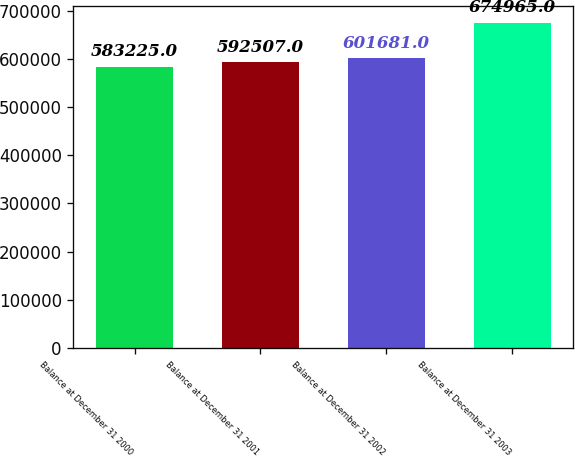Convert chart to OTSL. <chart><loc_0><loc_0><loc_500><loc_500><bar_chart><fcel>Balance at December 31 2000<fcel>Balance at December 31 2001<fcel>Balance at December 31 2002<fcel>Balance at December 31 2003<nl><fcel>583225<fcel>592507<fcel>601681<fcel>674965<nl></chart> 